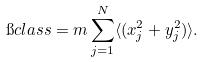Convert formula to latex. <formula><loc_0><loc_0><loc_500><loc_500>\i c l a s s = m \sum _ { j = 1 } ^ { N } \langle ( x _ { j } ^ { 2 } + y _ { j } ^ { 2 } ) \rangle .</formula> 